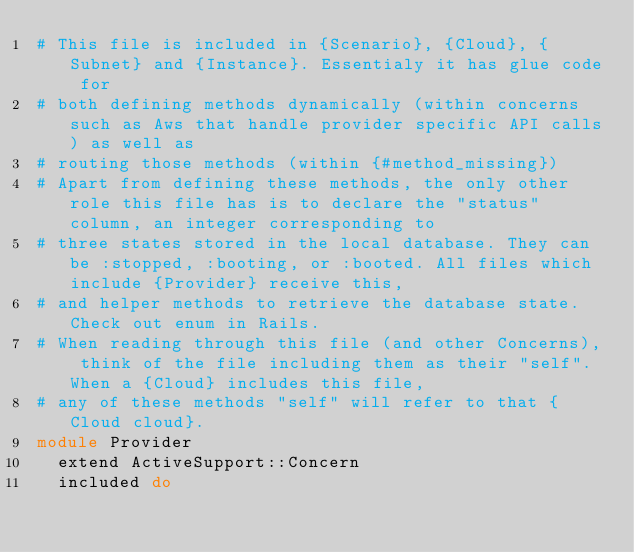<code> <loc_0><loc_0><loc_500><loc_500><_Ruby_># This file is included in {Scenario}, {Cloud}, {Subnet} and {Instance}. Essentialy it has glue code for
# both defining methods dynamically (within concerns such as Aws that handle provider specific API calls) as well as
# routing those methods (within {#method_missing})
# Apart from defining these methods, the only other role this file has is to declare the "status" column, an integer corresponding to
# three states stored in the local database. They can be :stopped, :booting, or :booted. All files which include {Provider} receive this,
# and helper methods to retrieve the database state. Check out enum in Rails.
# When reading through this file (and other Concerns), think of the file including them as their "self". When a {Cloud} includes this file,
# any of these methods "self" will refer to that {Cloud cloud}.
module Provider
  extend ActiveSupport::Concern
  included do</code> 